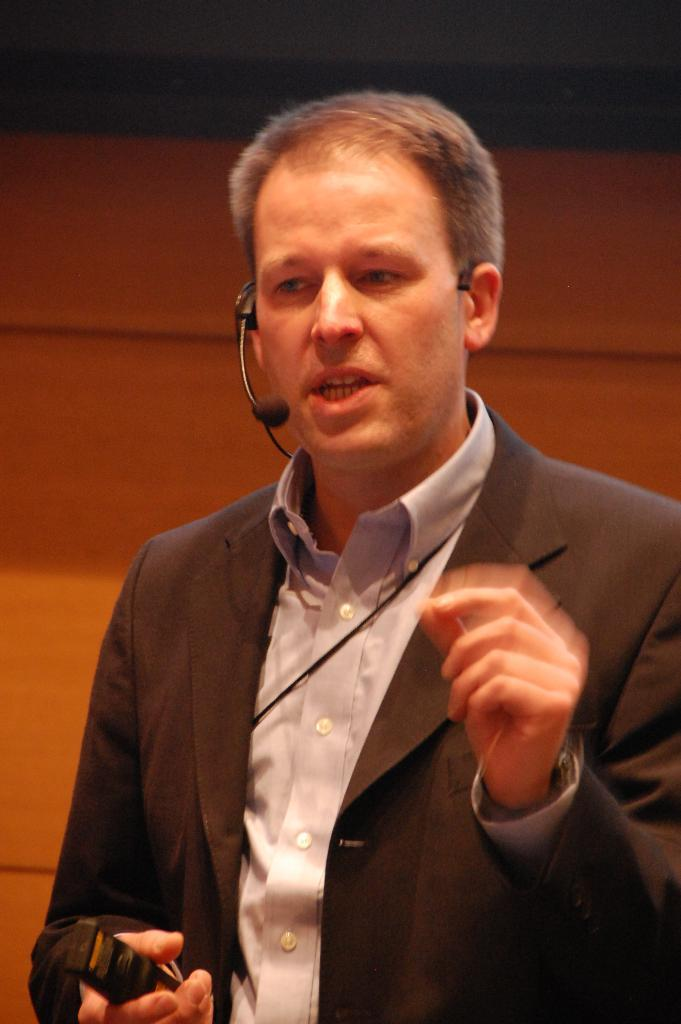What is the main subject of the image? There is a person in the image. What is the person holding in his hand? The person is holding a remote in his hand. What device is the person wearing on his ear? The person is wearing a microphone on his ear. What is the person doing with the microphone? The person is talking on the microphone. What can be seen in the background of the image? There is a wall visible in the background of the image. What is the slope of the appliance in the image? There is no appliance present in the image, and therefore no slope can be determined. 